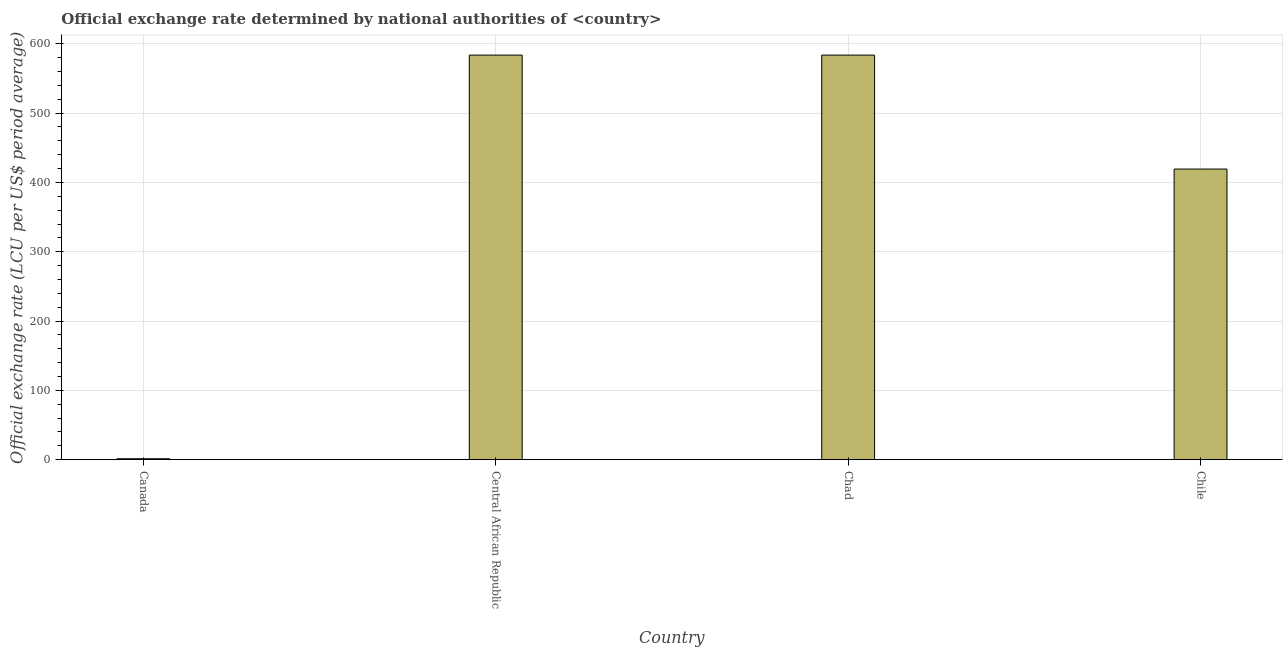What is the title of the graph?
Provide a succinct answer. Official exchange rate determined by national authorities of <country>. What is the label or title of the Y-axis?
Provide a short and direct response. Official exchange rate (LCU per US$ period average). What is the official exchange rate in Chile?
Provide a succinct answer. 419.3. Across all countries, what is the maximum official exchange rate?
Your response must be concise. 583.67. Across all countries, what is the minimum official exchange rate?
Keep it short and to the point. 1.38. In which country was the official exchange rate maximum?
Provide a short and direct response. Central African Republic. In which country was the official exchange rate minimum?
Give a very brief answer. Canada. What is the sum of the official exchange rate?
Your response must be concise. 1588.02. What is the difference between the official exchange rate in Canada and Chad?
Your response must be concise. -582.28. What is the average official exchange rate per country?
Offer a very short reply. 397. What is the median official exchange rate?
Provide a short and direct response. 501.48. What is the ratio of the official exchange rate in Canada to that in Chad?
Offer a terse response. 0. Is the official exchange rate in Canada less than that in Chile?
Keep it short and to the point. Yes. Is the difference between the official exchange rate in Central African Republic and Chile greater than the difference between any two countries?
Provide a succinct answer. No. Is the sum of the official exchange rate in Central African Republic and Chile greater than the maximum official exchange rate across all countries?
Your answer should be very brief. Yes. What is the difference between the highest and the lowest official exchange rate?
Keep it short and to the point. 582.28. Are all the bars in the graph horizontal?
Your answer should be very brief. No. How many countries are there in the graph?
Your answer should be compact. 4. What is the difference between two consecutive major ticks on the Y-axis?
Provide a succinct answer. 100. What is the Official exchange rate (LCU per US$ period average) in Canada?
Your response must be concise. 1.38. What is the Official exchange rate (LCU per US$ period average) of Central African Republic?
Provide a succinct answer. 583.67. What is the Official exchange rate (LCU per US$ period average) in Chad?
Make the answer very short. 583.67. What is the Official exchange rate (LCU per US$ period average) of Chile?
Offer a terse response. 419.3. What is the difference between the Official exchange rate (LCU per US$ period average) in Canada and Central African Republic?
Make the answer very short. -582.28. What is the difference between the Official exchange rate (LCU per US$ period average) in Canada and Chad?
Provide a short and direct response. -582.28. What is the difference between the Official exchange rate (LCU per US$ period average) in Canada and Chile?
Make the answer very short. -417.91. What is the difference between the Official exchange rate (LCU per US$ period average) in Central African Republic and Chile?
Your response must be concise. 164.37. What is the difference between the Official exchange rate (LCU per US$ period average) in Chad and Chile?
Make the answer very short. 164.37. What is the ratio of the Official exchange rate (LCU per US$ period average) in Canada to that in Central African Republic?
Give a very brief answer. 0. What is the ratio of the Official exchange rate (LCU per US$ period average) in Canada to that in Chad?
Give a very brief answer. 0. What is the ratio of the Official exchange rate (LCU per US$ period average) in Canada to that in Chile?
Your answer should be very brief. 0. What is the ratio of the Official exchange rate (LCU per US$ period average) in Central African Republic to that in Chad?
Your answer should be compact. 1. What is the ratio of the Official exchange rate (LCU per US$ period average) in Central African Republic to that in Chile?
Offer a very short reply. 1.39. What is the ratio of the Official exchange rate (LCU per US$ period average) in Chad to that in Chile?
Provide a succinct answer. 1.39. 